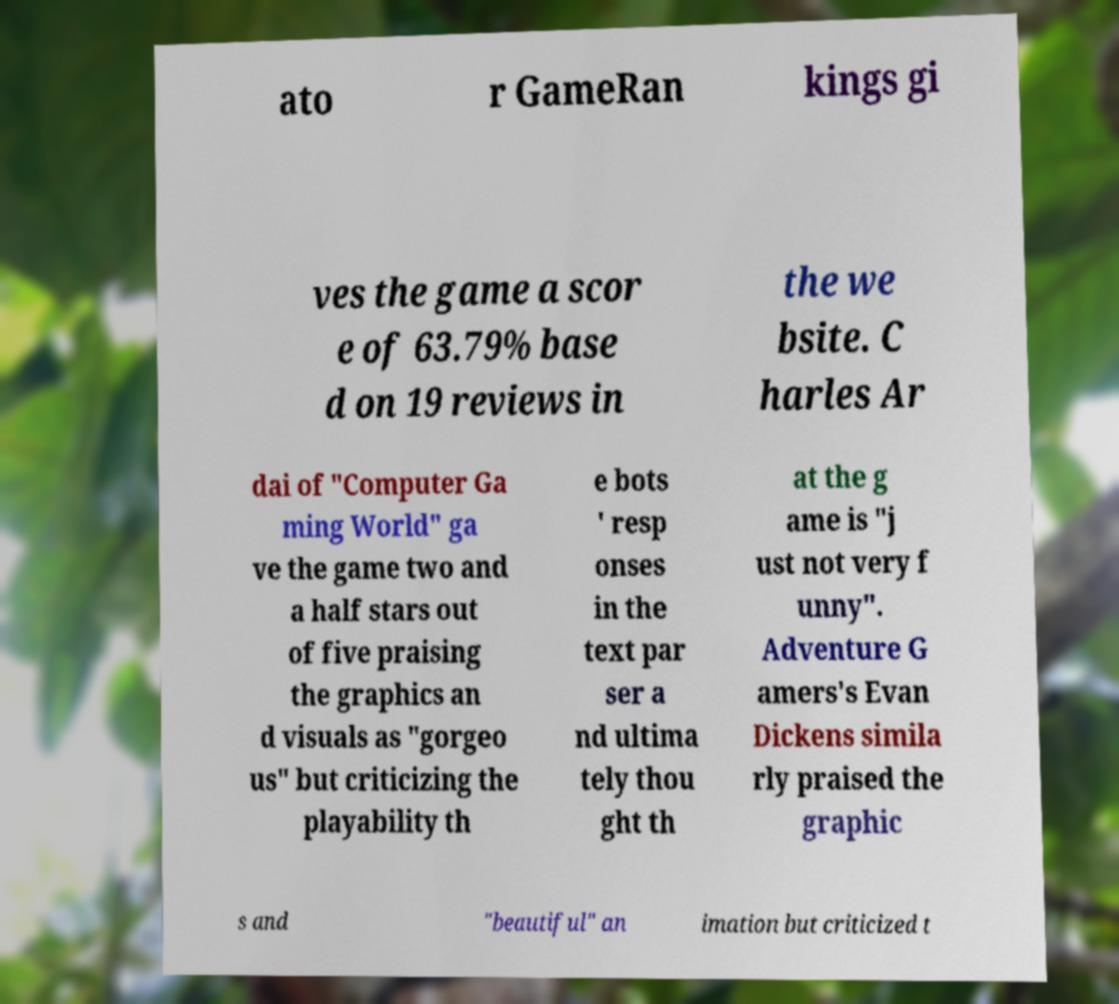Could you extract and type out the text from this image? ato r GameRan kings gi ves the game a scor e of 63.79% base d on 19 reviews in the we bsite. C harles Ar dai of "Computer Ga ming World" ga ve the game two and a half stars out of five praising the graphics an d visuals as "gorgeo us" but criticizing the playability th e bots ' resp onses in the text par ser a nd ultima tely thou ght th at the g ame is "j ust not very f unny". Adventure G amers's Evan Dickens simila rly praised the graphic s and "beautiful" an imation but criticized t 